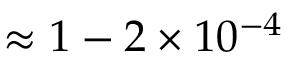Convert formula to latex. <formula><loc_0><loc_0><loc_500><loc_500>\approx 1 - 2 \times 1 0 ^ { - 4 }</formula> 